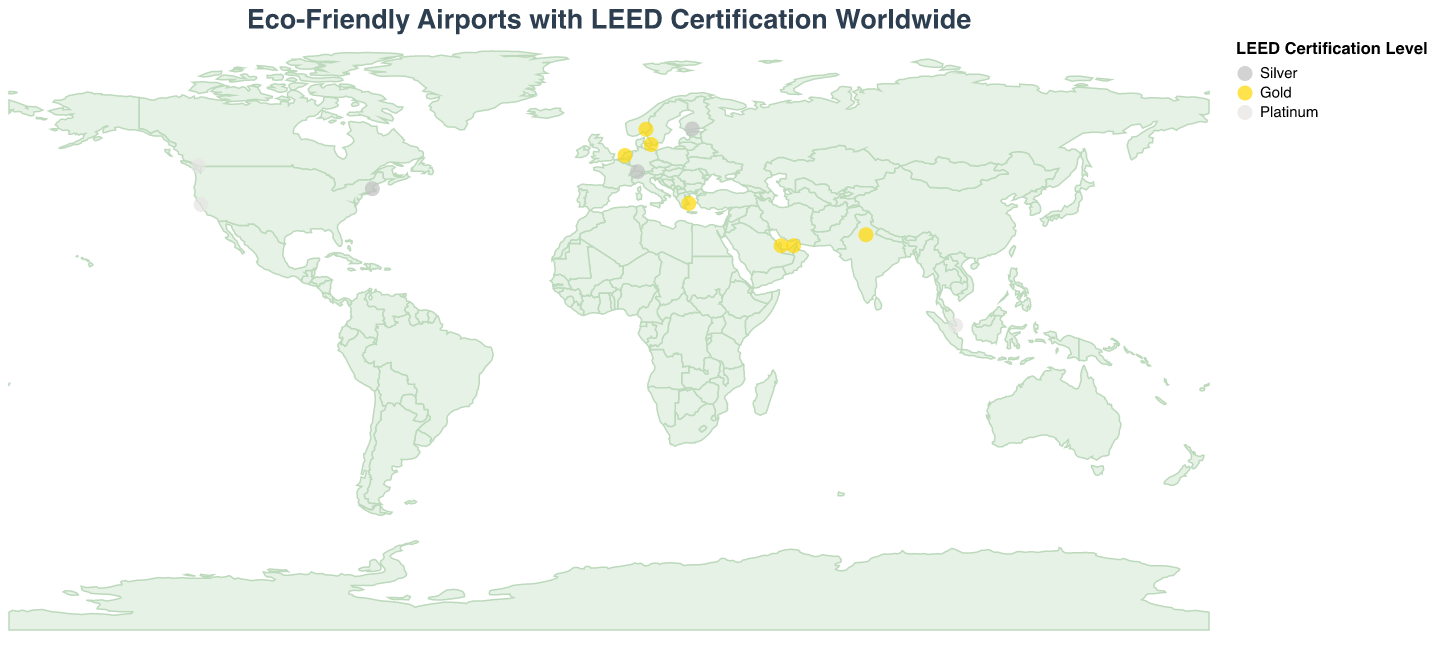What's the title of the figure? The title is usually displayed at the top of the figure. Here, it is written in a larger font and summarizes what the figure is about.
Answer: Eco-Friendly Airports with LEED Certification Worldwide How many airports are depicted on the map? To determine the number of airports, count the number of data points (circles) on the map. Each circle represents an airport.
Answer: 13 Which LEED certification level has the most airports? The color of the circles represents the LEED certification level. Count the number of circles for each color to find the most frequent one.
Answer: Gold Are there any Platinum-certified airports in Europe? Examine the color-coded circles that represent airports in Europe and check if any of them are in the Platinum range color.
Answer: No Which country has the airport with the highest LEED certification in North America? Identify the countries in North America and check the LEED certification levels of their airports. Only Platinum-certified airports will meet the highest standard.
Answer: Canada Which LEED certification level is represented by the color silver on the map? Refer to the legend on the map which matches the colors to LEED certification levels.
Answer: Silver What is the latitude and longitude of Athens International Airport? Check the tooltip information that appears when you highlight or refer to the data point of Athens International Airport.
Answer: Latitude: 37.9364, Longitude: 23.9445 How many airports are there in the United States, and what are their LEED levels? Identify all the data points representing airports in the United States and check their LEED certification levels listed in the tooltip.
Answer: 2 airports; San Francisco International Airport (Platinum) and Boston Logan International Airport (Silver) Which of the represented airports is in the Middle East region and what is its LEED certification level? Identify the data points in the Middle East region by geography and check their LEED certification levels.
Answer: Dubai International Airport (Gold) and Hamad International Airport (Gold) What is the average LEED certification level among the European airports on the map? Identify all the airports located in Europe and their respective LEED certification levels. Assign numerical values (e.g., Silver = 1, Gold = 2, Platinum = 3) then calculate the average. Detailed analysis required here since each category value might require additional justification.
Answer: 1.67 (European airports in Greece, Norway, Switzerland, Denmark, Netherlands, and Finland have levels Gold, Gold, Silver, Gold, Gold, Silver \[2, 2, 1, 2, 2, 1\] -> (2+2+1+2+2+1)/6 = 1.67) 